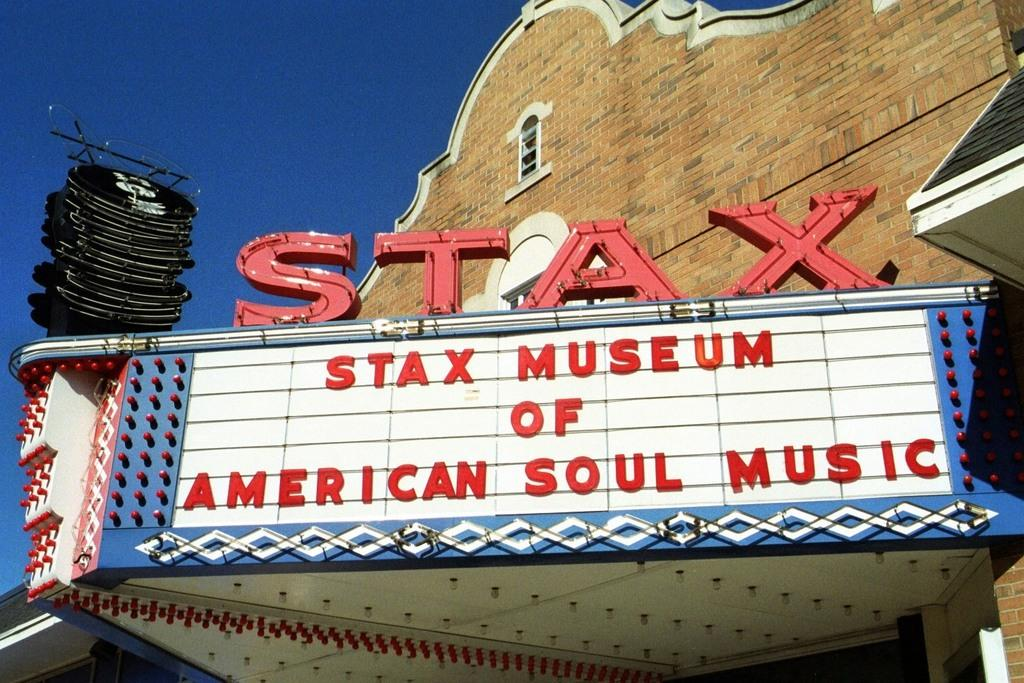What can be found in the image that contains written information? There is text in the image. What type of illumination is present in the image? There are lights in the image. What type of wall is visible in the image? There is a brick wall in the image. What color is the sky in the image? The sky is blue in color. What type of object is black in the image? There is a black object in the image. What other objects can be seen on a building in the image? Other objects are visible on a building in the image. What type of fuel is being used by the porter in the image? There is no porter present in the image, and therefore no fuel usage can be observed. What type of work is being done by the objects on the building in the image? The objects on the building are not performing any work; they are stationary and not engaged in any activity. 